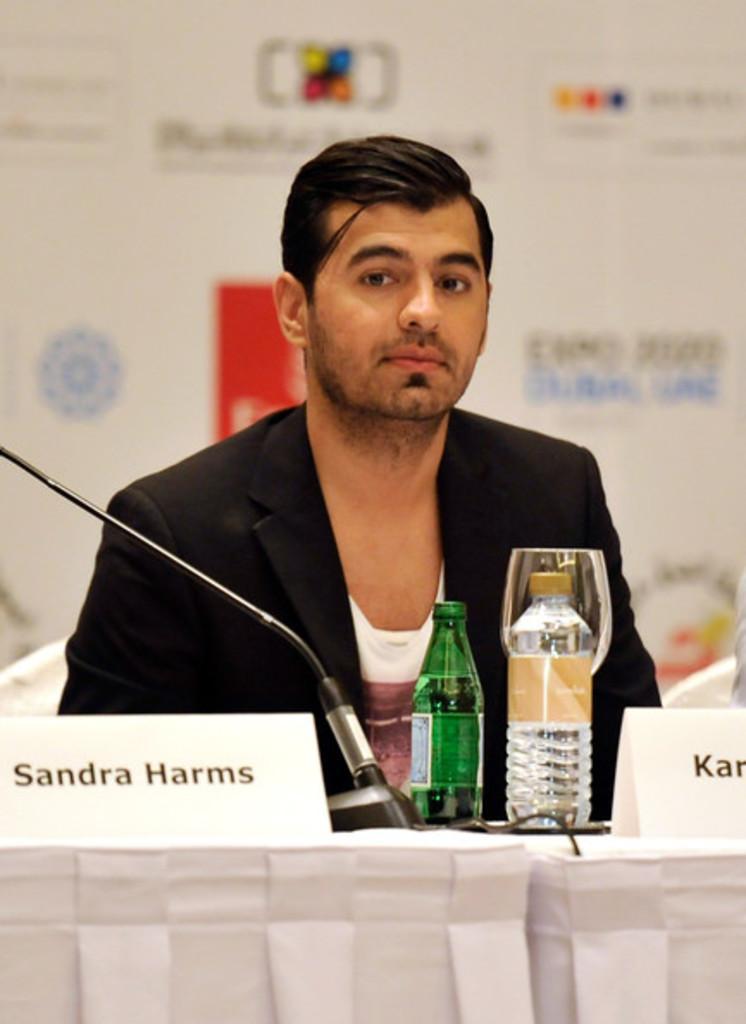Could you give a brief overview of what you see in this image? In this picture we can see a man who is in black suit. These are the bottles. And this is the table. On the background there is a hoarding. 